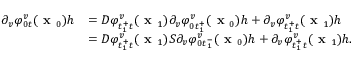Convert formula to latex. <formula><loc_0><loc_0><loc_500><loc_500>\begin{array} { r l } { \partial _ { v } \varphi _ { 0 t } ^ { v } ( x _ { 0 } ) h } & { = D \varphi _ { t _ { 1 } ^ { + } t } ^ { v } ( x _ { 1 } ) \partial _ { v } \varphi _ { 0 t _ { 1 } ^ { + } } ^ { v } ( x _ { 0 } ) h + \partial _ { v } \varphi _ { t _ { 1 } ^ { + } t } ^ { v } ( x _ { 1 } ) h } \\ & { = D \varphi _ { t _ { 1 } ^ { + } t } ^ { v } ( x _ { 1 } ) S \partial _ { v } \varphi _ { 0 t _ { 1 } ^ { - } } ^ { v } ( x _ { 0 } ) h + \partial _ { v } \varphi _ { t _ { 1 } ^ { + } t } ^ { v } ( x _ { 1 } ) h . } \end{array}</formula> 